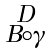Convert formula to latex. <formula><loc_0><loc_0><loc_500><loc_500>\begin{smallmatrix} D \\ B \circ \gamma \end{smallmatrix}</formula> 